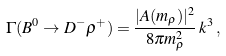Convert formula to latex. <formula><loc_0><loc_0><loc_500><loc_500>\Gamma ( B ^ { 0 } \rightarrow D ^ { - } \rho ^ { + } ) = \frac { | A ( m _ { \rho } ) | ^ { 2 } } { 8 \pi m ^ { 2 } _ { \rho } } \, k ^ { 3 } \, ,</formula> 